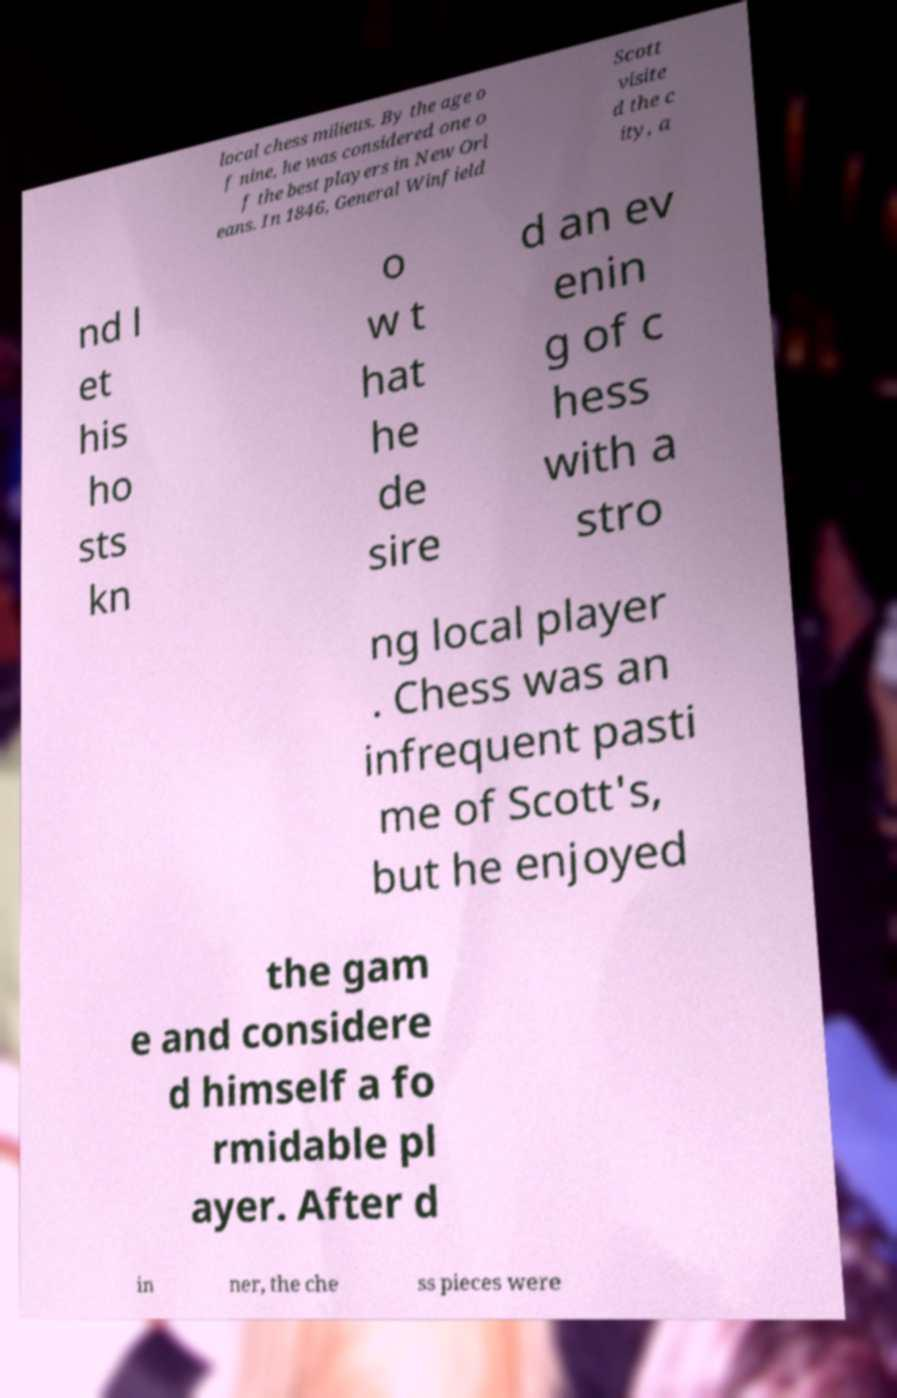I need the written content from this picture converted into text. Can you do that? local chess milieus. By the age o f nine, he was considered one o f the best players in New Orl eans. In 1846, General Winfield Scott visite d the c ity, a nd l et his ho sts kn o w t hat he de sire d an ev enin g of c hess with a stro ng local player . Chess was an infrequent pasti me of Scott's, but he enjoyed the gam e and considere d himself a fo rmidable pl ayer. After d in ner, the che ss pieces were 